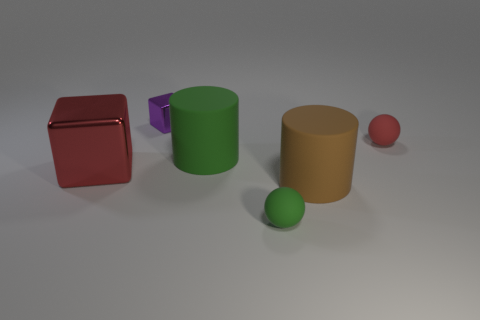There is a matte thing that is both on the right side of the green ball and in front of the red rubber thing; what is its color?
Your answer should be compact. Brown. What number of objects are rubber cylinders on the left side of the green sphere or shiny things in front of the tiny red ball?
Your answer should be compact. 2. What color is the rubber ball to the left of the big matte thing that is in front of the red object that is to the left of the green matte ball?
Provide a short and direct response. Green. Is there a small red object that has the same shape as the tiny green rubber object?
Provide a succinct answer. Yes. How many red rubber cylinders are there?
Your answer should be compact. 0. The large shiny object has what shape?
Make the answer very short. Cube. How many green cylinders have the same size as the red matte thing?
Offer a terse response. 0. Does the big green object have the same shape as the tiny purple thing?
Ensure brevity in your answer.  No. There is a small ball that is on the left side of the brown cylinder that is on the right side of the tiny shiny object; what is its color?
Your response must be concise. Green. There is a matte object that is both to the left of the red rubber object and behind the big metallic cube; how big is it?
Give a very brief answer. Large. 